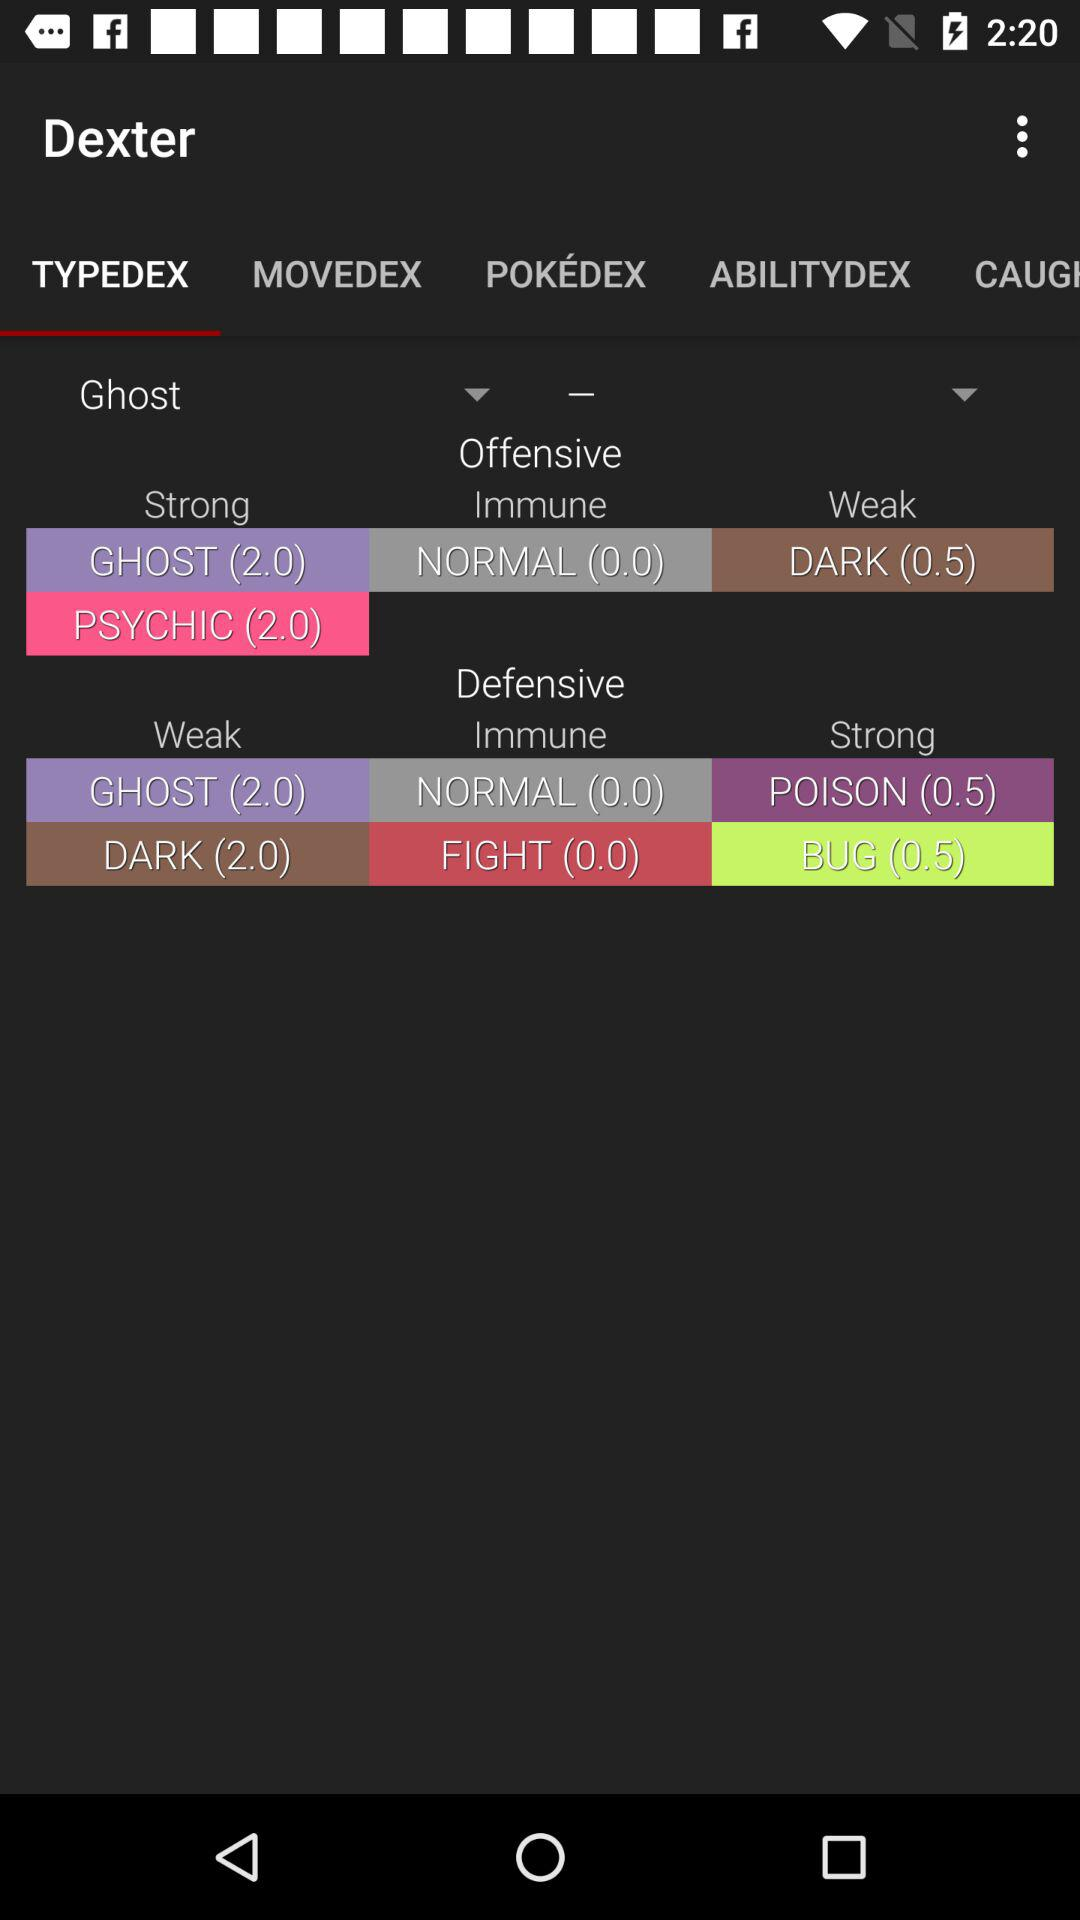Which tab is selected? The selected tab is "TYPEDEX". 